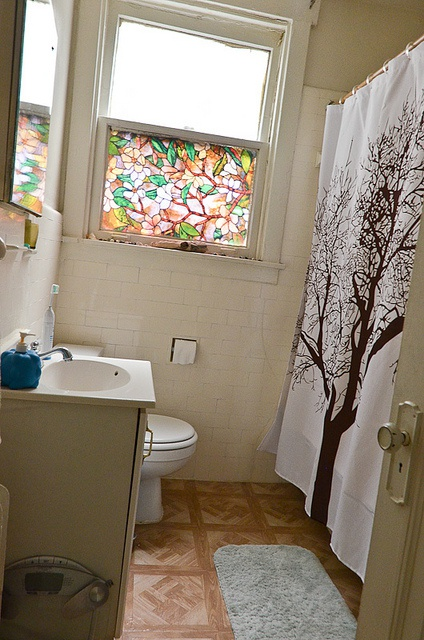Describe the objects in this image and their specific colors. I can see toilet in gray, darkgray, and lightgray tones, sink in gray, darkgray, and lightgray tones, and bottle in gray, darkgray, and lightgray tones in this image. 